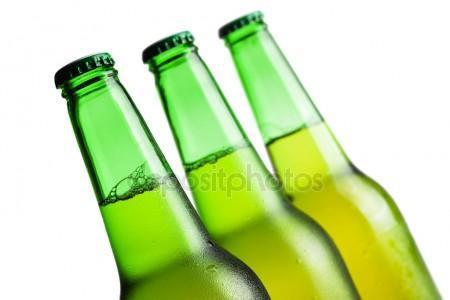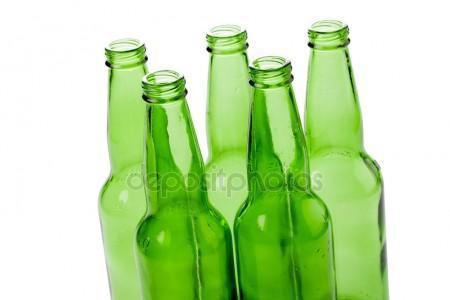The first image is the image on the left, the second image is the image on the right. Given the left and right images, does the statement "All the bottles are full." hold true? Answer yes or no. No. 